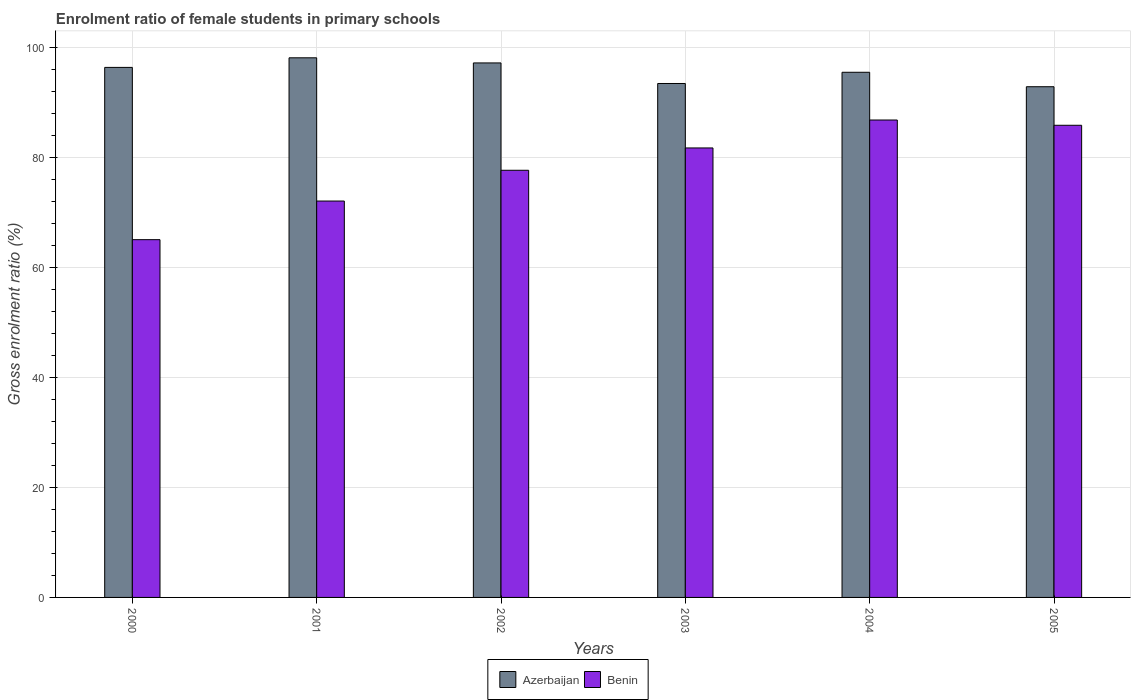How many groups of bars are there?
Give a very brief answer. 6. Are the number of bars per tick equal to the number of legend labels?
Give a very brief answer. Yes. Are the number of bars on each tick of the X-axis equal?
Provide a succinct answer. Yes. How many bars are there on the 3rd tick from the right?
Offer a very short reply. 2. What is the label of the 3rd group of bars from the left?
Provide a short and direct response. 2002. What is the enrolment ratio of female students in primary schools in Azerbaijan in 2002?
Ensure brevity in your answer.  97.11. Across all years, what is the maximum enrolment ratio of female students in primary schools in Benin?
Keep it short and to the point. 86.74. Across all years, what is the minimum enrolment ratio of female students in primary schools in Azerbaijan?
Ensure brevity in your answer.  92.78. What is the total enrolment ratio of female students in primary schools in Azerbaijan in the graph?
Your answer should be very brief. 573. What is the difference between the enrolment ratio of female students in primary schools in Benin in 2002 and that in 2004?
Offer a very short reply. -9.13. What is the difference between the enrolment ratio of female students in primary schools in Azerbaijan in 2005 and the enrolment ratio of female students in primary schools in Benin in 2001?
Provide a succinct answer. 20.77. What is the average enrolment ratio of female students in primary schools in Azerbaijan per year?
Your answer should be very brief. 95.5. In the year 2000, what is the difference between the enrolment ratio of female students in primary schools in Benin and enrolment ratio of female students in primary schools in Azerbaijan?
Provide a short and direct response. -31.3. What is the ratio of the enrolment ratio of female students in primary schools in Azerbaijan in 2000 to that in 2002?
Provide a short and direct response. 0.99. Is the difference between the enrolment ratio of female students in primary schools in Benin in 2000 and 2004 greater than the difference between the enrolment ratio of female students in primary schools in Azerbaijan in 2000 and 2004?
Ensure brevity in your answer.  No. What is the difference between the highest and the second highest enrolment ratio of female students in primary schools in Benin?
Your response must be concise. 0.96. What is the difference between the highest and the lowest enrolment ratio of female students in primary schools in Azerbaijan?
Ensure brevity in your answer.  5.25. In how many years, is the enrolment ratio of female students in primary schools in Benin greater than the average enrolment ratio of female students in primary schools in Benin taken over all years?
Offer a terse response. 3. Is the sum of the enrolment ratio of female students in primary schools in Azerbaijan in 2001 and 2003 greater than the maximum enrolment ratio of female students in primary schools in Benin across all years?
Keep it short and to the point. Yes. What does the 2nd bar from the left in 2002 represents?
Your answer should be very brief. Benin. What does the 1st bar from the right in 2002 represents?
Your answer should be very brief. Benin. How many years are there in the graph?
Your answer should be very brief. 6. What is the difference between two consecutive major ticks on the Y-axis?
Keep it short and to the point. 20. Are the values on the major ticks of Y-axis written in scientific E-notation?
Give a very brief answer. No. Does the graph contain grids?
Provide a short and direct response. Yes. Where does the legend appear in the graph?
Provide a succinct answer. Bottom center. What is the title of the graph?
Your answer should be compact. Enrolment ratio of female students in primary schools. Does "Niger" appear as one of the legend labels in the graph?
Provide a short and direct response. No. What is the label or title of the X-axis?
Ensure brevity in your answer.  Years. What is the label or title of the Y-axis?
Your answer should be compact. Gross enrolment ratio (%). What is the Gross enrolment ratio (%) in Azerbaijan in 2000?
Give a very brief answer. 96.29. What is the Gross enrolment ratio (%) of Benin in 2000?
Provide a short and direct response. 65. What is the Gross enrolment ratio (%) in Azerbaijan in 2001?
Offer a terse response. 98.04. What is the Gross enrolment ratio (%) in Benin in 2001?
Ensure brevity in your answer.  72.02. What is the Gross enrolment ratio (%) of Azerbaijan in 2002?
Your answer should be compact. 97.11. What is the Gross enrolment ratio (%) in Benin in 2002?
Provide a succinct answer. 77.6. What is the Gross enrolment ratio (%) in Azerbaijan in 2003?
Your answer should be compact. 93.37. What is the Gross enrolment ratio (%) of Benin in 2003?
Ensure brevity in your answer.  81.66. What is the Gross enrolment ratio (%) of Azerbaijan in 2004?
Give a very brief answer. 95.41. What is the Gross enrolment ratio (%) of Benin in 2004?
Your answer should be very brief. 86.74. What is the Gross enrolment ratio (%) in Azerbaijan in 2005?
Keep it short and to the point. 92.78. What is the Gross enrolment ratio (%) in Benin in 2005?
Give a very brief answer. 85.78. Across all years, what is the maximum Gross enrolment ratio (%) of Azerbaijan?
Provide a short and direct response. 98.04. Across all years, what is the maximum Gross enrolment ratio (%) in Benin?
Give a very brief answer. 86.74. Across all years, what is the minimum Gross enrolment ratio (%) of Azerbaijan?
Your answer should be very brief. 92.78. Across all years, what is the minimum Gross enrolment ratio (%) in Benin?
Offer a very short reply. 65. What is the total Gross enrolment ratio (%) of Azerbaijan in the graph?
Your answer should be very brief. 573. What is the total Gross enrolment ratio (%) of Benin in the graph?
Provide a succinct answer. 468.8. What is the difference between the Gross enrolment ratio (%) of Azerbaijan in 2000 and that in 2001?
Provide a short and direct response. -1.74. What is the difference between the Gross enrolment ratio (%) of Benin in 2000 and that in 2001?
Your answer should be compact. -7.02. What is the difference between the Gross enrolment ratio (%) in Azerbaijan in 2000 and that in 2002?
Your answer should be very brief. -0.81. What is the difference between the Gross enrolment ratio (%) in Benin in 2000 and that in 2002?
Provide a succinct answer. -12.61. What is the difference between the Gross enrolment ratio (%) of Azerbaijan in 2000 and that in 2003?
Ensure brevity in your answer.  2.92. What is the difference between the Gross enrolment ratio (%) in Benin in 2000 and that in 2003?
Provide a short and direct response. -16.66. What is the difference between the Gross enrolment ratio (%) in Azerbaijan in 2000 and that in 2004?
Your answer should be compact. 0.88. What is the difference between the Gross enrolment ratio (%) of Benin in 2000 and that in 2004?
Offer a very short reply. -21.74. What is the difference between the Gross enrolment ratio (%) of Azerbaijan in 2000 and that in 2005?
Provide a succinct answer. 3.51. What is the difference between the Gross enrolment ratio (%) in Benin in 2000 and that in 2005?
Your answer should be very brief. -20.78. What is the difference between the Gross enrolment ratio (%) of Azerbaijan in 2001 and that in 2002?
Offer a very short reply. 0.93. What is the difference between the Gross enrolment ratio (%) in Benin in 2001 and that in 2002?
Keep it short and to the point. -5.59. What is the difference between the Gross enrolment ratio (%) of Azerbaijan in 2001 and that in 2003?
Ensure brevity in your answer.  4.67. What is the difference between the Gross enrolment ratio (%) of Benin in 2001 and that in 2003?
Provide a short and direct response. -9.65. What is the difference between the Gross enrolment ratio (%) of Azerbaijan in 2001 and that in 2004?
Provide a succinct answer. 2.63. What is the difference between the Gross enrolment ratio (%) in Benin in 2001 and that in 2004?
Your answer should be very brief. -14.72. What is the difference between the Gross enrolment ratio (%) in Azerbaijan in 2001 and that in 2005?
Offer a very short reply. 5.25. What is the difference between the Gross enrolment ratio (%) in Benin in 2001 and that in 2005?
Your response must be concise. -13.77. What is the difference between the Gross enrolment ratio (%) in Azerbaijan in 2002 and that in 2003?
Your answer should be compact. 3.74. What is the difference between the Gross enrolment ratio (%) of Benin in 2002 and that in 2003?
Ensure brevity in your answer.  -4.06. What is the difference between the Gross enrolment ratio (%) of Azerbaijan in 2002 and that in 2004?
Give a very brief answer. 1.7. What is the difference between the Gross enrolment ratio (%) in Benin in 2002 and that in 2004?
Keep it short and to the point. -9.13. What is the difference between the Gross enrolment ratio (%) of Azerbaijan in 2002 and that in 2005?
Offer a very short reply. 4.32. What is the difference between the Gross enrolment ratio (%) in Benin in 2002 and that in 2005?
Your answer should be compact. -8.18. What is the difference between the Gross enrolment ratio (%) in Azerbaijan in 2003 and that in 2004?
Give a very brief answer. -2.04. What is the difference between the Gross enrolment ratio (%) of Benin in 2003 and that in 2004?
Your answer should be compact. -5.08. What is the difference between the Gross enrolment ratio (%) in Azerbaijan in 2003 and that in 2005?
Your answer should be compact. 0.59. What is the difference between the Gross enrolment ratio (%) of Benin in 2003 and that in 2005?
Provide a short and direct response. -4.12. What is the difference between the Gross enrolment ratio (%) in Azerbaijan in 2004 and that in 2005?
Give a very brief answer. 2.63. What is the difference between the Gross enrolment ratio (%) of Benin in 2004 and that in 2005?
Provide a succinct answer. 0.96. What is the difference between the Gross enrolment ratio (%) in Azerbaijan in 2000 and the Gross enrolment ratio (%) in Benin in 2001?
Keep it short and to the point. 24.28. What is the difference between the Gross enrolment ratio (%) in Azerbaijan in 2000 and the Gross enrolment ratio (%) in Benin in 2002?
Give a very brief answer. 18.69. What is the difference between the Gross enrolment ratio (%) in Azerbaijan in 2000 and the Gross enrolment ratio (%) in Benin in 2003?
Provide a short and direct response. 14.63. What is the difference between the Gross enrolment ratio (%) in Azerbaijan in 2000 and the Gross enrolment ratio (%) in Benin in 2004?
Give a very brief answer. 9.56. What is the difference between the Gross enrolment ratio (%) of Azerbaijan in 2000 and the Gross enrolment ratio (%) of Benin in 2005?
Ensure brevity in your answer.  10.51. What is the difference between the Gross enrolment ratio (%) of Azerbaijan in 2001 and the Gross enrolment ratio (%) of Benin in 2002?
Keep it short and to the point. 20.43. What is the difference between the Gross enrolment ratio (%) of Azerbaijan in 2001 and the Gross enrolment ratio (%) of Benin in 2003?
Make the answer very short. 16.38. What is the difference between the Gross enrolment ratio (%) in Azerbaijan in 2001 and the Gross enrolment ratio (%) in Benin in 2004?
Keep it short and to the point. 11.3. What is the difference between the Gross enrolment ratio (%) of Azerbaijan in 2001 and the Gross enrolment ratio (%) of Benin in 2005?
Provide a short and direct response. 12.26. What is the difference between the Gross enrolment ratio (%) of Azerbaijan in 2002 and the Gross enrolment ratio (%) of Benin in 2003?
Ensure brevity in your answer.  15.45. What is the difference between the Gross enrolment ratio (%) of Azerbaijan in 2002 and the Gross enrolment ratio (%) of Benin in 2004?
Your answer should be compact. 10.37. What is the difference between the Gross enrolment ratio (%) in Azerbaijan in 2002 and the Gross enrolment ratio (%) in Benin in 2005?
Keep it short and to the point. 11.33. What is the difference between the Gross enrolment ratio (%) of Azerbaijan in 2003 and the Gross enrolment ratio (%) of Benin in 2004?
Ensure brevity in your answer.  6.63. What is the difference between the Gross enrolment ratio (%) in Azerbaijan in 2003 and the Gross enrolment ratio (%) in Benin in 2005?
Keep it short and to the point. 7.59. What is the difference between the Gross enrolment ratio (%) in Azerbaijan in 2004 and the Gross enrolment ratio (%) in Benin in 2005?
Offer a very short reply. 9.63. What is the average Gross enrolment ratio (%) in Azerbaijan per year?
Ensure brevity in your answer.  95.5. What is the average Gross enrolment ratio (%) of Benin per year?
Make the answer very short. 78.13. In the year 2000, what is the difference between the Gross enrolment ratio (%) of Azerbaijan and Gross enrolment ratio (%) of Benin?
Your response must be concise. 31.3. In the year 2001, what is the difference between the Gross enrolment ratio (%) of Azerbaijan and Gross enrolment ratio (%) of Benin?
Make the answer very short. 26.02. In the year 2002, what is the difference between the Gross enrolment ratio (%) of Azerbaijan and Gross enrolment ratio (%) of Benin?
Your response must be concise. 19.5. In the year 2003, what is the difference between the Gross enrolment ratio (%) of Azerbaijan and Gross enrolment ratio (%) of Benin?
Offer a very short reply. 11.71. In the year 2004, what is the difference between the Gross enrolment ratio (%) in Azerbaijan and Gross enrolment ratio (%) in Benin?
Provide a short and direct response. 8.67. In the year 2005, what is the difference between the Gross enrolment ratio (%) of Azerbaijan and Gross enrolment ratio (%) of Benin?
Your answer should be very brief. 7. What is the ratio of the Gross enrolment ratio (%) of Azerbaijan in 2000 to that in 2001?
Your response must be concise. 0.98. What is the ratio of the Gross enrolment ratio (%) in Benin in 2000 to that in 2001?
Ensure brevity in your answer.  0.9. What is the ratio of the Gross enrolment ratio (%) in Benin in 2000 to that in 2002?
Ensure brevity in your answer.  0.84. What is the ratio of the Gross enrolment ratio (%) in Azerbaijan in 2000 to that in 2003?
Offer a terse response. 1.03. What is the ratio of the Gross enrolment ratio (%) in Benin in 2000 to that in 2003?
Make the answer very short. 0.8. What is the ratio of the Gross enrolment ratio (%) of Azerbaijan in 2000 to that in 2004?
Your response must be concise. 1.01. What is the ratio of the Gross enrolment ratio (%) of Benin in 2000 to that in 2004?
Make the answer very short. 0.75. What is the ratio of the Gross enrolment ratio (%) of Azerbaijan in 2000 to that in 2005?
Give a very brief answer. 1.04. What is the ratio of the Gross enrolment ratio (%) of Benin in 2000 to that in 2005?
Offer a terse response. 0.76. What is the ratio of the Gross enrolment ratio (%) of Azerbaijan in 2001 to that in 2002?
Provide a short and direct response. 1.01. What is the ratio of the Gross enrolment ratio (%) of Benin in 2001 to that in 2002?
Provide a succinct answer. 0.93. What is the ratio of the Gross enrolment ratio (%) of Azerbaijan in 2001 to that in 2003?
Offer a very short reply. 1.05. What is the ratio of the Gross enrolment ratio (%) in Benin in 2001 to that in 2003?
Provide a short and direct response. 0.88. What is the ratio of the Gross enrolment ratio (%) of Azerbaijan in 2001 to that in 2004?
Keep it short and to the point. 1.03. What is the ratio of the Gross enrolment ratio (%) of Benin in 2001 to that in 2004?
Ensure brevity in your answer.  0.83. What is the ratio of the Gross enrolment ratio (%) of Azerbaijan in 2001 to that in 2005?
Keep it short and to the point. 1.06. What is the ratio of the Gross enrolment ratio (%) of Benin in 2001 to that in 2005?
Make the answer very short. 0.84. What is the ratio of the Gross enrolment ratio (%) in Benin in 2002 to that in 2003?
Your answer should be compact. 0.95. What is the ratio of the Gross enrolment ratio (%) in Azerbaijan in 2002 to that in 2004?
Keep it short and to the point. 1.02. What is the ratio of the Gross enrolment ratio (%) in Benin in 2002 to that in 2004?
Provide a short and direct response. 0.89. What is the ratio of the Gross enrolment ratio (%) of Azerbaijan in 2002 to that in 2005?
Your answer should be compact. 1.05. What is the ratio of the Gross enrolment ratio (%) in Benin in 2002 to that in 2005?
Provide a succinct answer. 0.9. What is the ratio of the Gross enrolment ratio (%) in Azerbaijan in 2003 to that in 2004?
Provide a succinct answer. 0.98. What is the ratio of the Gross enrolment ratio (%) in Benin in 2003 to that in 2004?
Your response must be concise. 0.94. What is the ratio of the Gross enrolment ratio (%) in Azerbaijan in 2004 to that in 2005?
Your answer should be compact. 1.03. What is the ratio of the Gross enrolment ratio (%) of Benin in 2004 to that in 2005?
Your answer should be compact. 1.01. What is the difference between the highest and the second highest Gross enrolment ratio (%) of Benin?
Give a very brief answer. 0.96. What is the difference between the highest and the lowest Gross enrolment ratio (%) in Azerbaijan?
Ensure brevity in your answer.  5.25. What is the difference between the highest and the lowest Gross enrolment ratio (%) in Benin?
Ensure brevity in your answer.  21.74. 